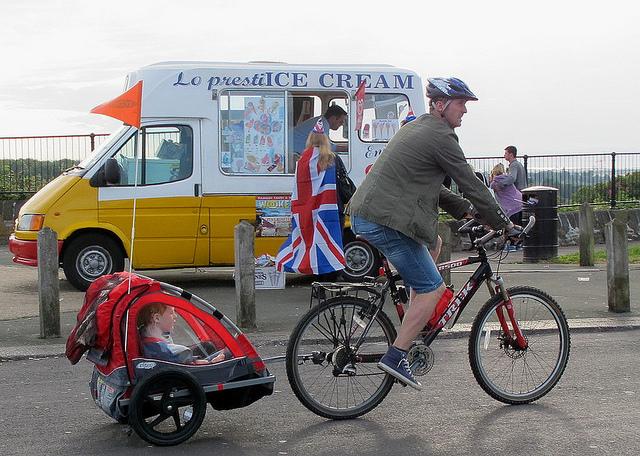What is the man pulling with his bike?
Answer briefly. Baby. What color are the his shorts?
Quick response, please. Blue. What is being sold from the truck?
Keep it brief. Ice cream. Is this in the US?
Keep it brief. No. 